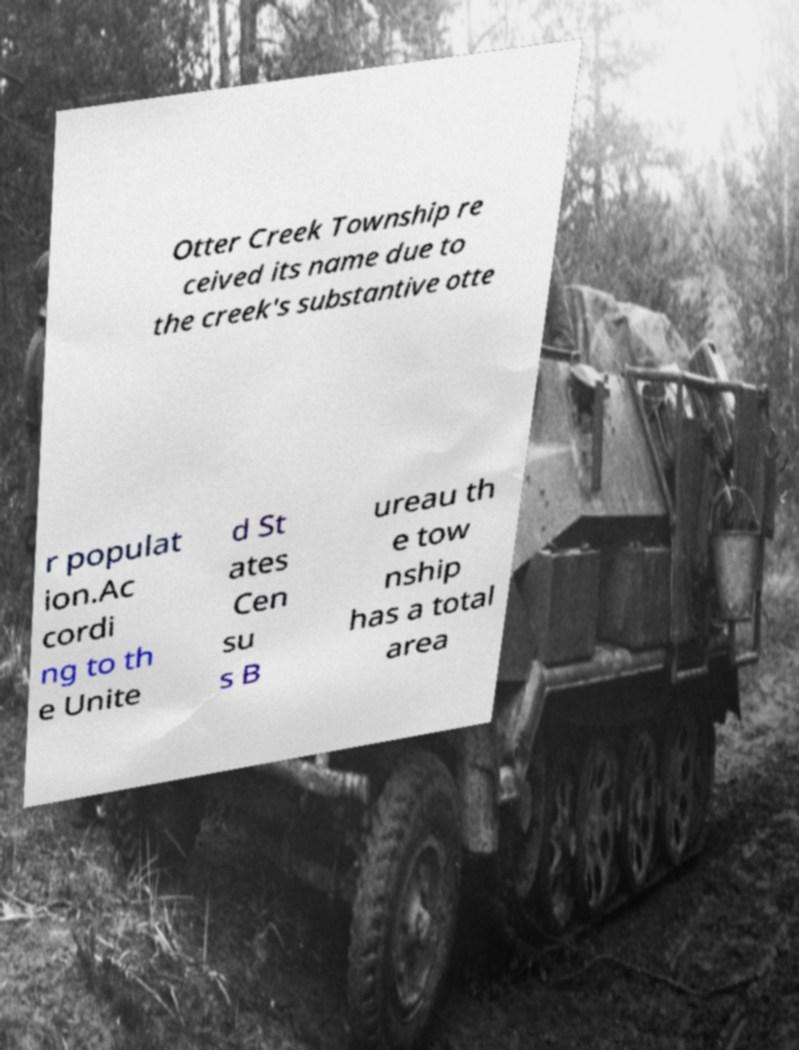What messages or text are displayed in this image? I need them in a readable, typed format. Otter Creek Township re ceived its name due to the creek's substantive otte r populat ion.Ac cordi ng to th e Unite d St ates Cen su s B ureau th e tow nship has a total area 